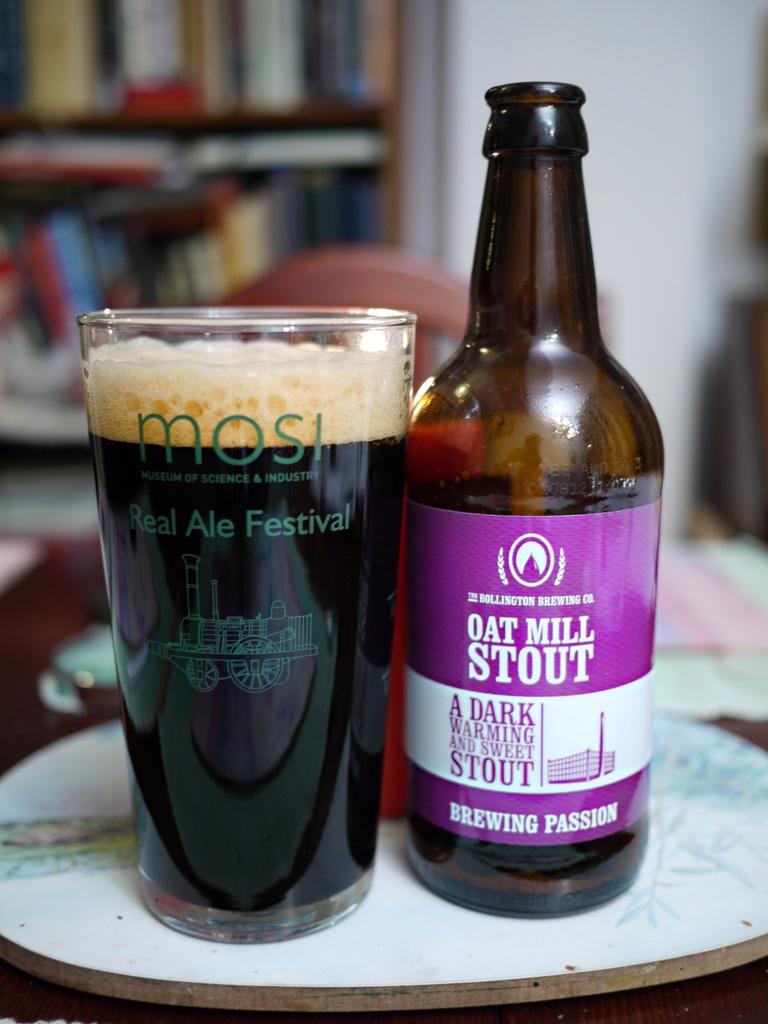What type of beer is this?
Make the answer very short. Oat mill stout. What type of festival is on the glass?
Offer a very short reply. Real ale festival. 